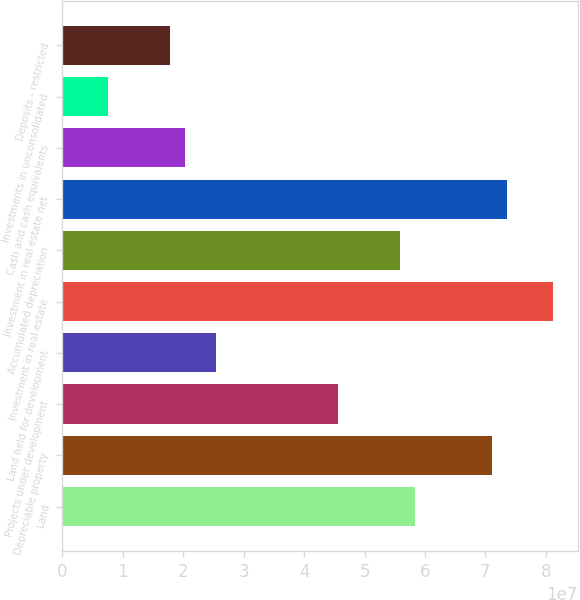Convert chart to OTSL. <chart><loc_0><loc_0><loc_500><loc_500><bar_chart><fcel>Land<fcel>Depreciable property<fcel>Projects under development<fcel>Land held for development<fcel>Investment in real estate<fcel>Accumulated depreciation<fcel>Investment in real estate net<fcel>Cash and cash equivalents<fcel>Investments in unconsolidated<fcel>Deposits - restricted<nl><fcel>5.8375e+07<fcel>7.10629e+07<fcel>4.56871e+07<fcel>2.53864e+07<fcel>8.12132e+07<fcel>5.58374e+07<fcel>7.36005e+07<fcel>2.03113e+07<fcel>7.62335e+06<fcel>1.77737e+07<nl></chart> 